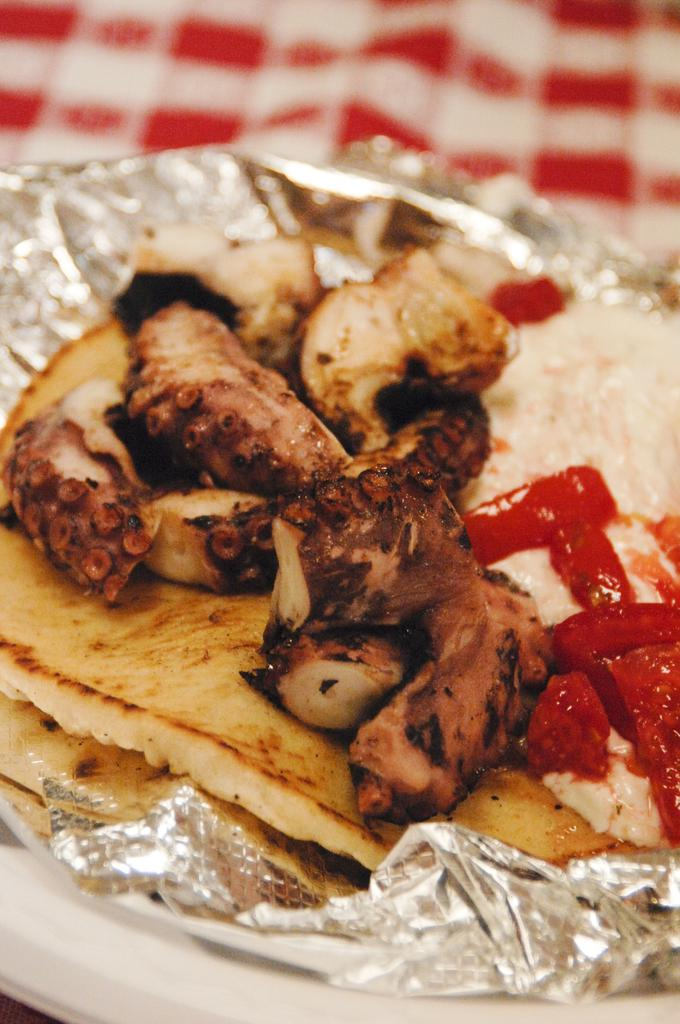What is the main subject of the image? There is a food item in the image. How is the food item presented? The food item is wrapped. Where is the wrapped food item located? The wrapper is on top of a plastic table. What does the aunt write in her notebook about her desire for the food item in the image? There is no aunt, notebook, or desire mentioned in the image, so it is not possible to answer that question. 